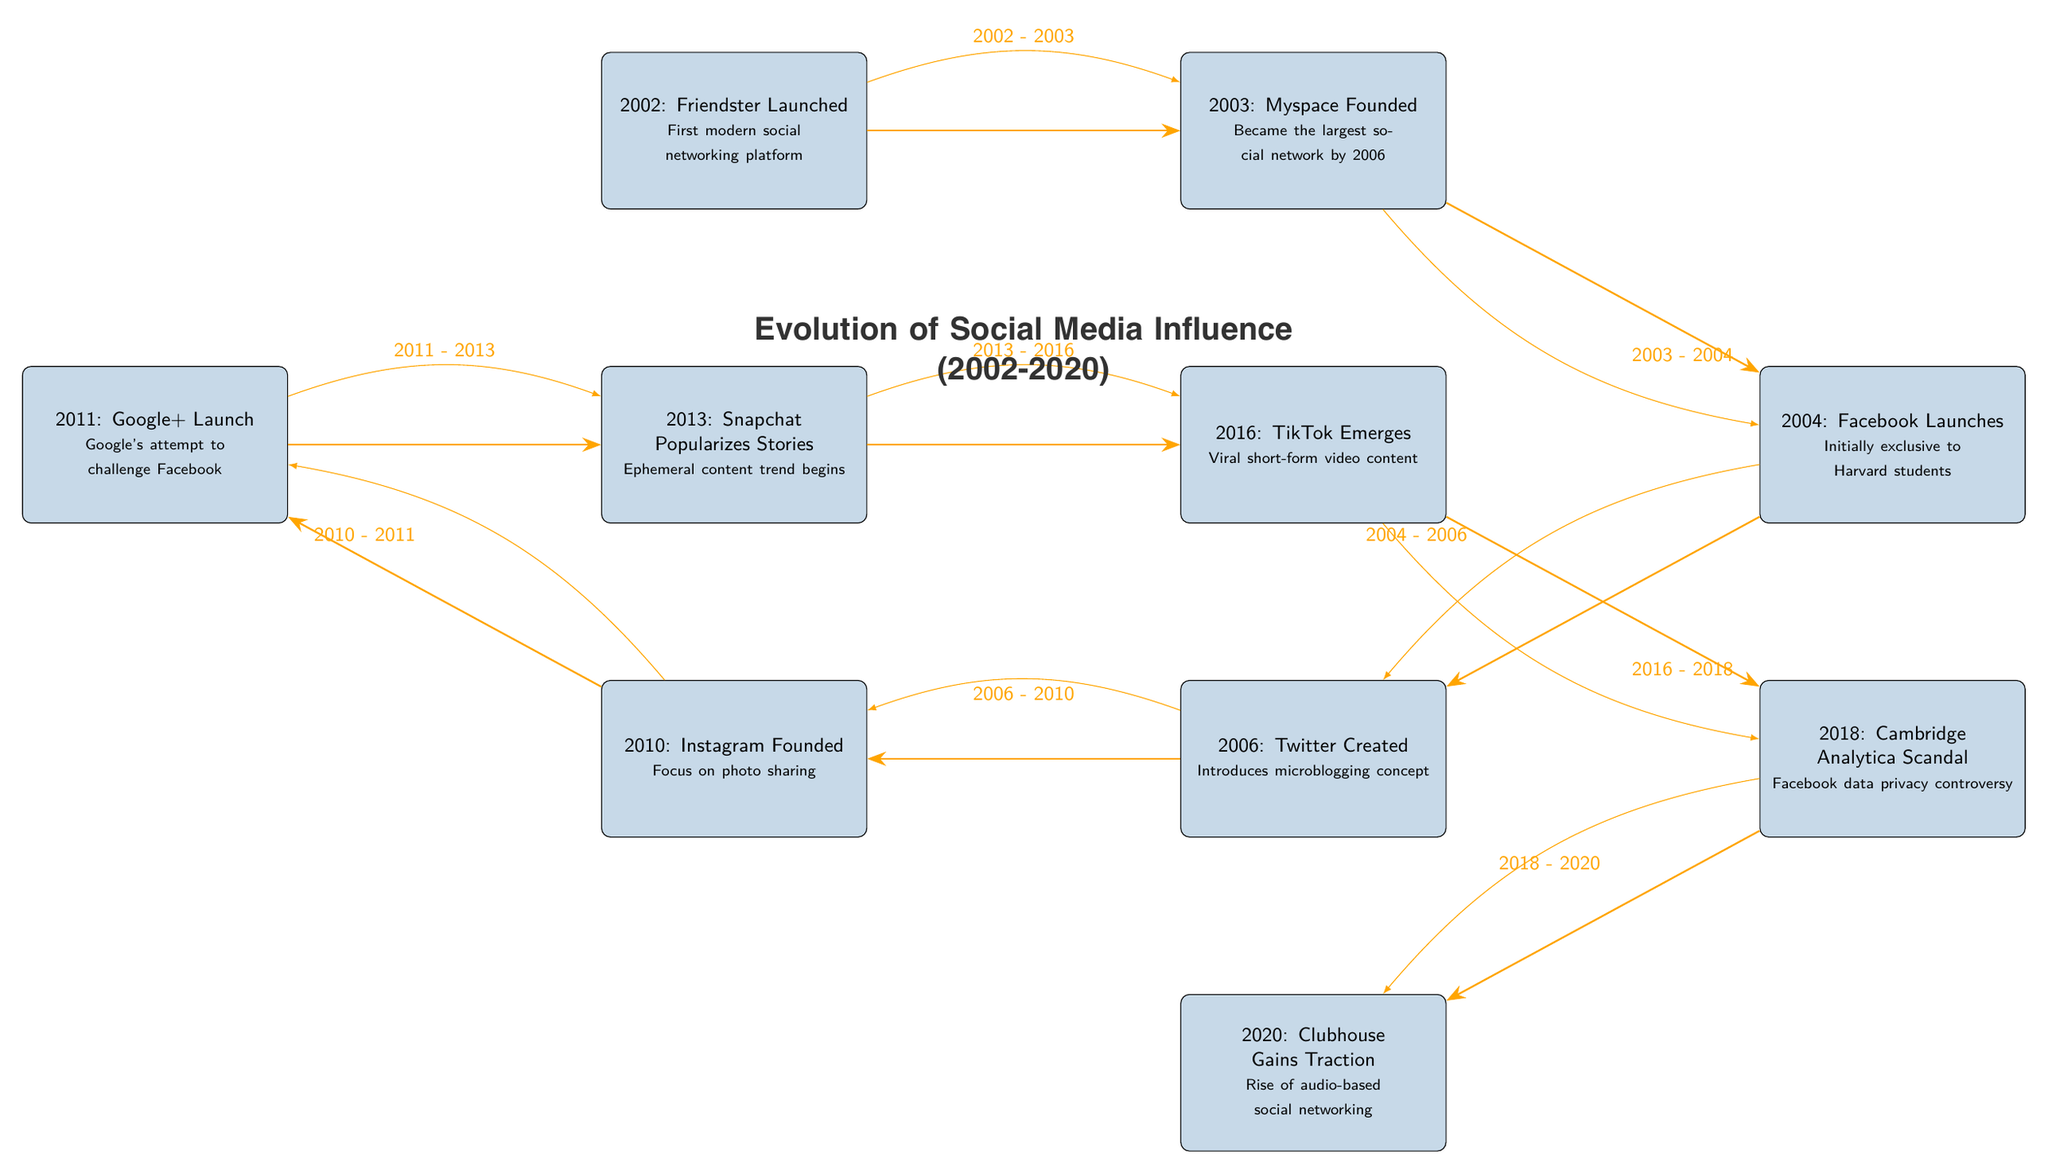What year was Friendster launched? The diagram indicates that Friendster was launched in 2002, which is shown as the first event on the timeline.
Answer: 2002 What major event occurred in 2013? According to the diagram, the major event in 2013 was the popularization of Stories by Snapchat, which is marked on the timeline.
Answer: Snapchat Popularizes Stories How many social media platforms are highlighted in the timeline? The diagram depicts a total of 10 events representing social media platforms throughout the timeline from 2002 to 2020.
Answer: 10 What is the first social media platform listed in the timeline? Based on the timeline, Friendster is the first social media platform listed, as shown in the event for 2002.
Answer: Friendster During which years did Facebook and Twitter exist simultaneously according to the timeline? The timeline shows that Facebook launched in 2004 and Twitter was created in 2006, so they existed simultaneously from 2006 to 2010, as represented by the years listed in the flow of events.
Answer: 2006 - 2010 What was a major significant scandal for Facebook and when did it occur? The diagram indicates that the Cambridge Analytica Scandal was a significant event for Facebook, occurring in 2018. This is clearly marked on the timeline of events.
Answer: Cambridge Analytica Scandal, 2018 Which platform introduced the microblogging concept? As per the timeline, Twitter, launched in 2006, is the platform that introduced the microblogging concept, which is specified in its event description.
Answer: Twitter Which two platforms focus on photo sharing and audio-based networking? The timeline shows Instagram, founded in 2010 for photo sharing, and Clubhouse, gaining traction in 2020 for audio-based networking. These can be identified based on their specific event descriptions on the timeline.
Answer: Instagram, Clubhouse What key event is associated with 2016 in the timeline? The timeline denotes TikTok's emergence in 2016, signifying the rise of viral short-form video content, which is crucial in understanding the social media landscape of that year.
Answer: TikTok Emerges 